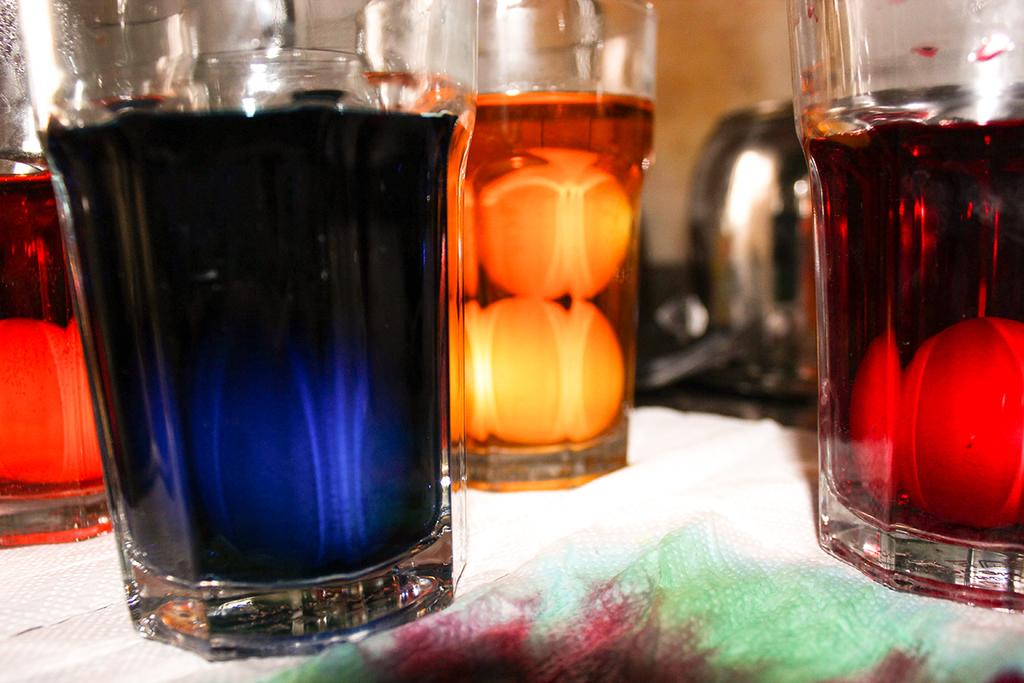What objects are in the image that people typically use for drinking? There are glasses in the image. What is inside the glasses? The glasses contain drinks in different colors. What is the surface on which the glasses are placed? There is a table in the image. What is covering the table? The table is covered with a cloth. What scent can be detected from the glasses in the image? There is no information about the scent of the drinks in the glasses, as the image only provides visual information. 